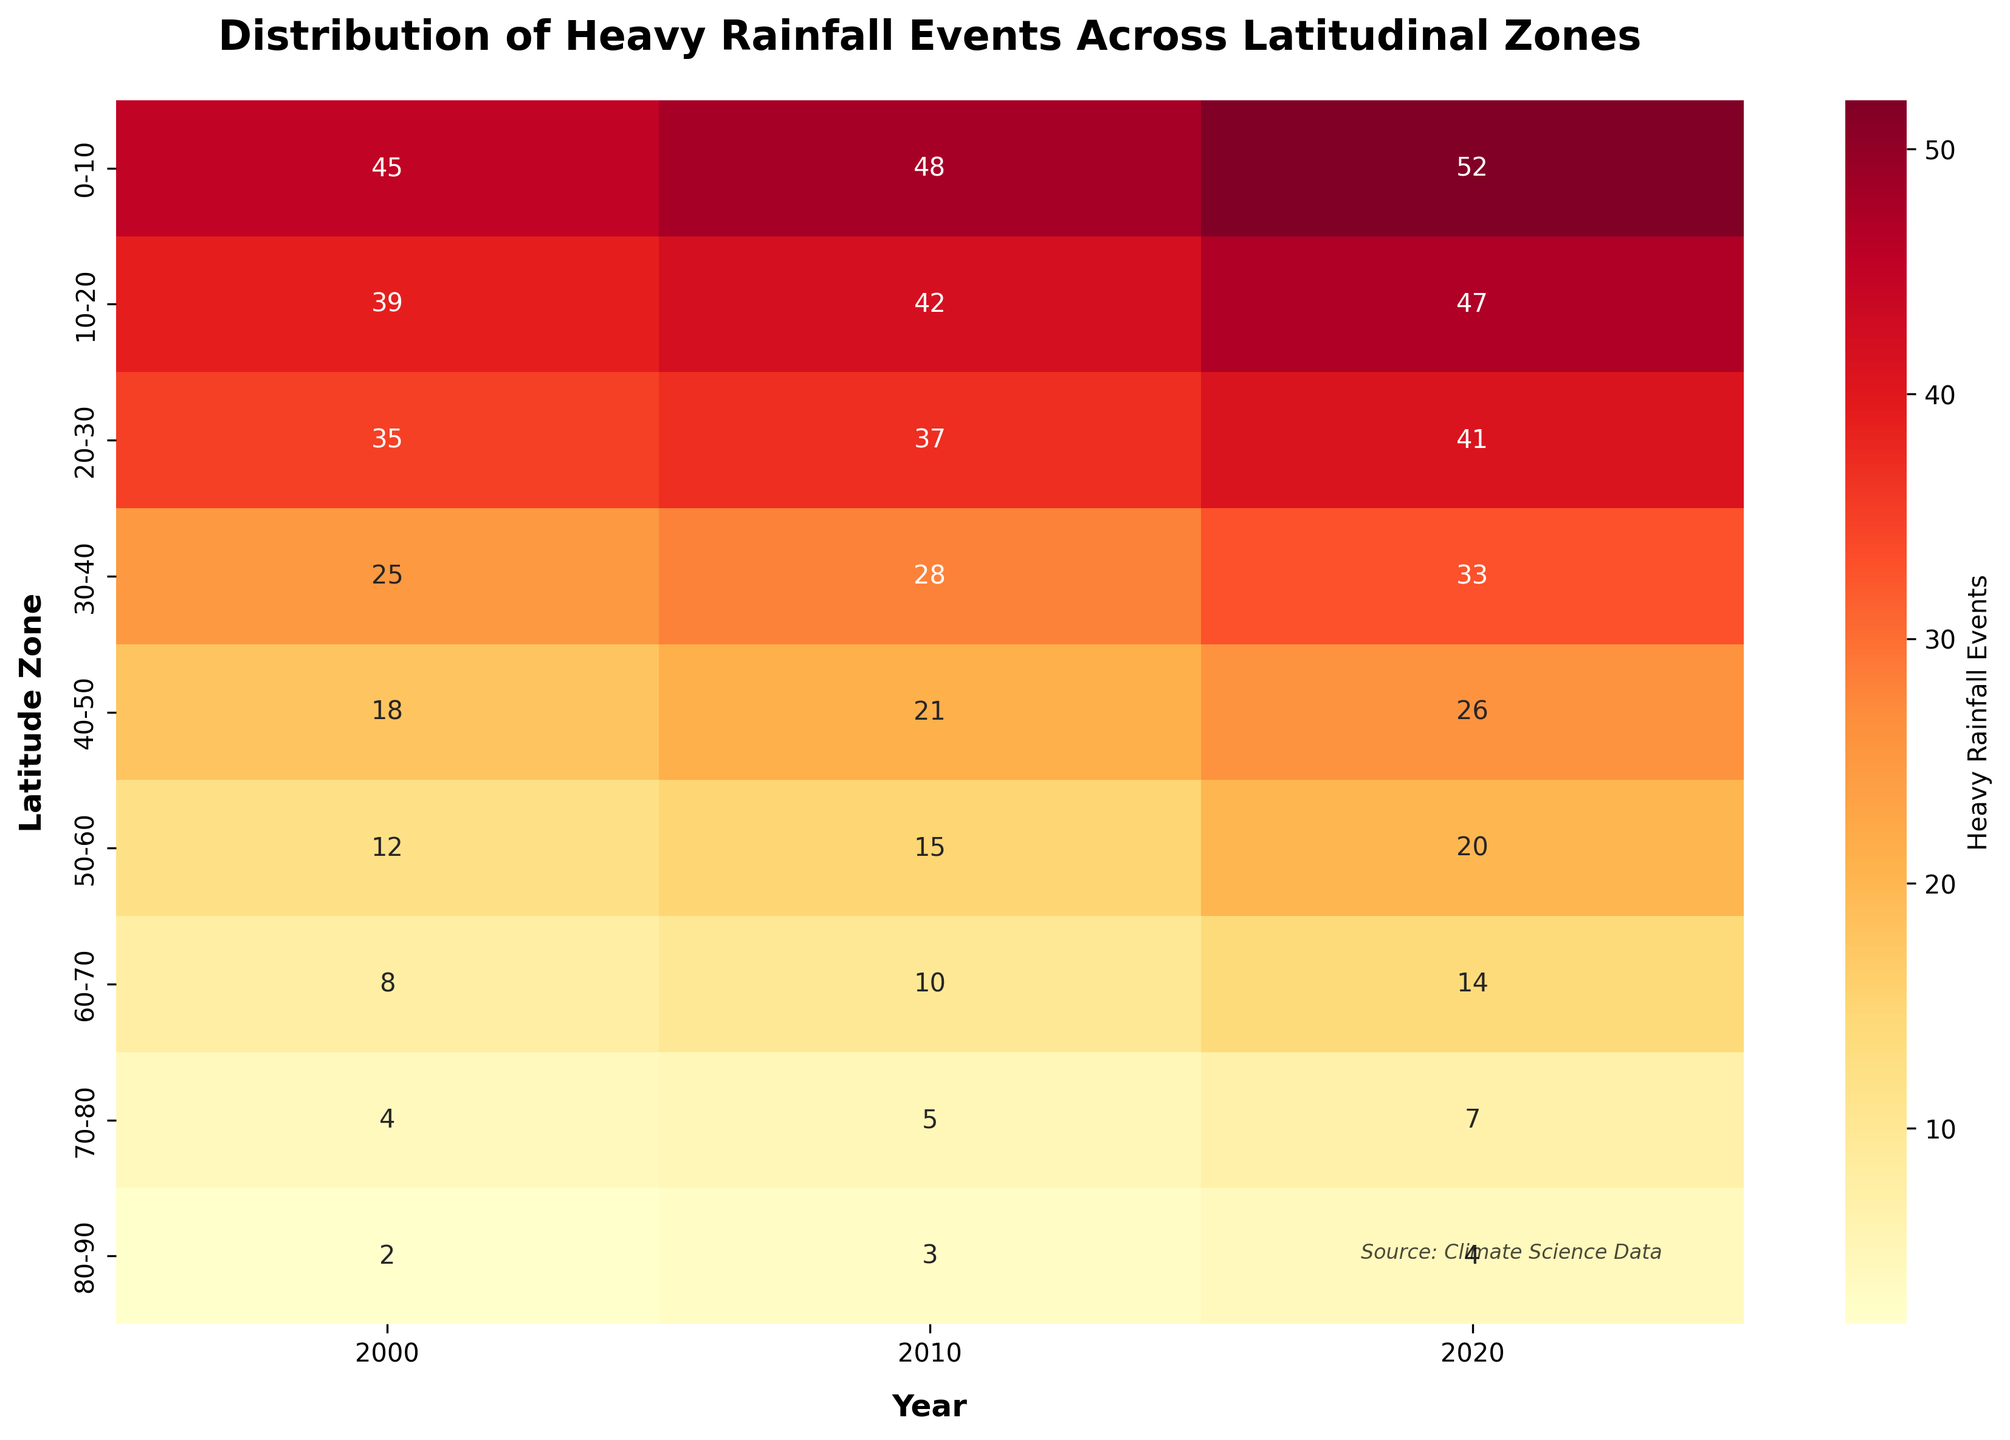What's the title of the heatmap? The title is typically found at the top of the heatmap and is clearly marked. The title helps understand the context of the data presented.
Answer: Distribution of Heavy Rainfall Events Across Latitudinal Zones How many latitudinal zones are there in the heatmap? Count the number of rows in the heatmap, each corresponding to a different latitudinal zone.
Answer: 9 Which latitudinal zone experienced the highest number of heavy rainfall events in 2020? Look at the intersection of the '2020' column and identify the row with the highest value.
Answer: 0-10 What is the trend in heavy rainfall events for the 0-10 latitude zone from 2000 to 2020? Examine the values in the row corresponding to the '0-10' latitude zone for the years 2000, 2010, and 2020.
Answer: Increasing How does the number of heavy rainfall events in the 40-50 latitude zone in 2000 compare to 2020? Look at the values for the '40-50' latitude zone for the years 2000 and 2020 and compare them.
Answer: The number increased from 18 to 26 Calculate the average number of heavy rainfall events for the 20-30 latitude zone over the three recorded years. Sum the values for the '20-30' latitude zone for 2000, 2010, and 2020, and then divide by 3. (35 + 37 + 41) / 3 = 113 / 3.
Answer: 37.67 Which latitudinal zone has the least increase in heavy rainfall events from 2000 to 2020? Subtract the 2000 values from the 2020 values for each zone, then identify the smallest difference.
Answer: 80-90 Is there any latitudinal zone where the number of heavy rainfall events decreased over the years? Check if any of the rows show a decrease from 2000 to 2020.
Answer: No What color range is used in the heatmap to encode the number of heavy rainfall events? Observe the color gradient used in the heatmap and mention the colors.
Answer: Yellow to Red 